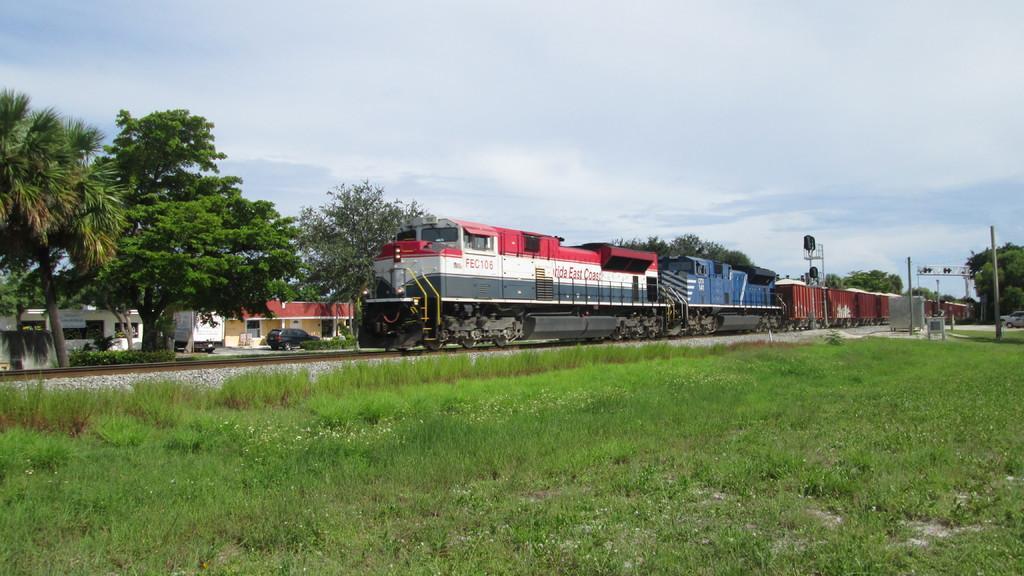Could you give a brief overview of what you see in this image? This is the train on the rail track. These are the trees. I can see a truck and a car on the road. This is the grass. I think these are the poles. I can see the bushes. There are two buildings. 